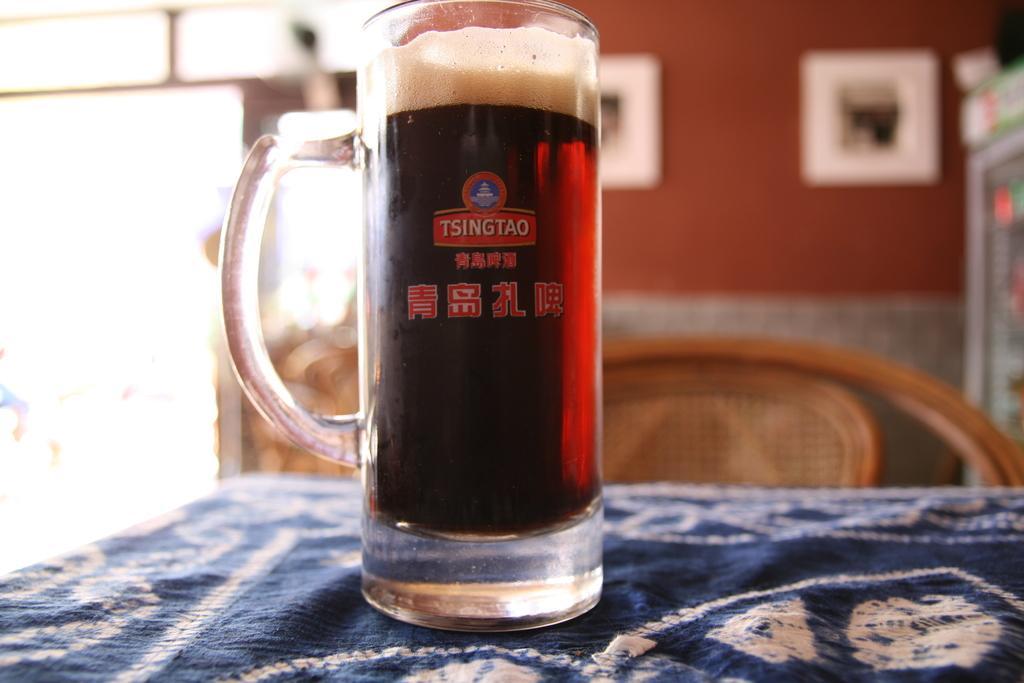Could you give a brief overview of what you see in this image? In this image, we can see a jug with liquid and foam on the cloth. On the jug, we can see text and logo. In the background, we can see the blur view, wooden chair, wall and few objects. 